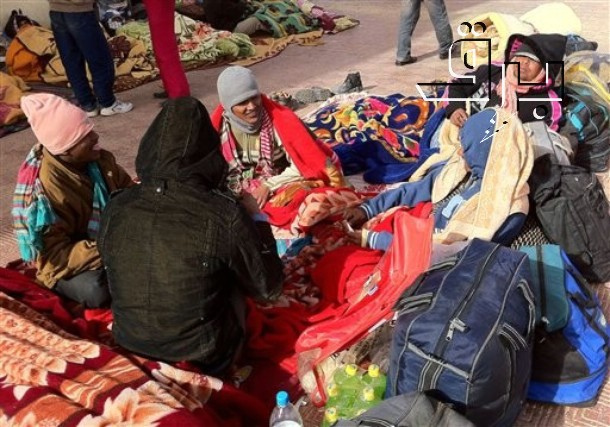What do you see happening in this image? In the vein of an aesthetic critique. This image beautifully encapsulates a scene of togetherness and communal warmth amidst a cold urban environment. The six individuals, four of whom are clearly visible, are cozily huddled together, wrapped in vibrant winter clothing and hats that both protect them from the cold and add a rich tapestry of colors to the scene. The ground is covered by an array of blankets and bags, which not only provide necessary insulation but also create a visually interesting composition. Two bottles of water and a red bag in the foreground add elements of practicality to the otherwise emotional scene. The backdrop of a building and trees gives context to their urban setting, hinting that they may be seeking comfort and community in the midst of city life. This image speaks to the resilience and connection found in human relationships during hardship, creating a powerful narrative of survival and solidarity. 